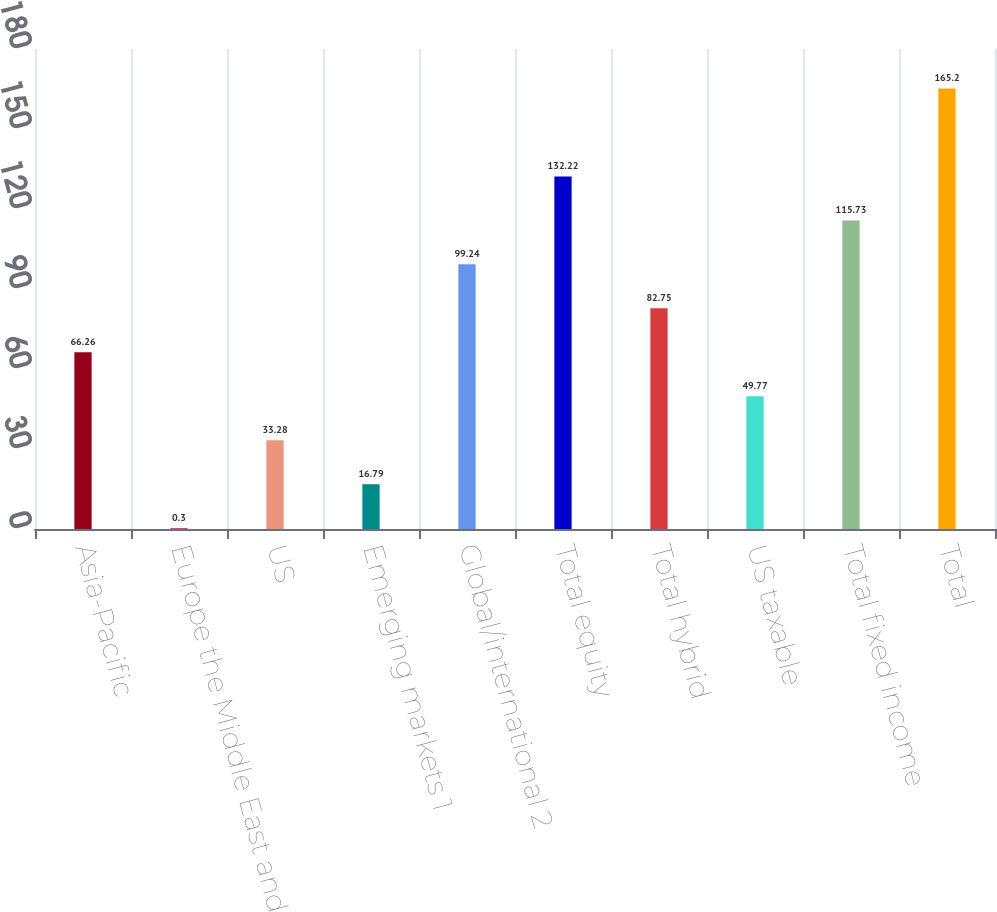Convert chart. <chart><loc_0><loc_0><loc_500><loc_500><bar_chart><fcel>Asia-Pacific<fcel>Europe the Middle East and<fcel>US<fcel>Emerging markets 1<fcel>Global/international 2<fcel>Total equity<fcel>Total hybrid<fcel>US taxable<fcel>Total fixed income<fcel>Total<nl><fcel>66.26<fcel>0.3<fcel>33.28<fcel>16.79<fcel>99.24<fcel>132.22<fcel>82.75<fcel>49.77<fcel>115.73<fcel>165.2<nl></chart> 